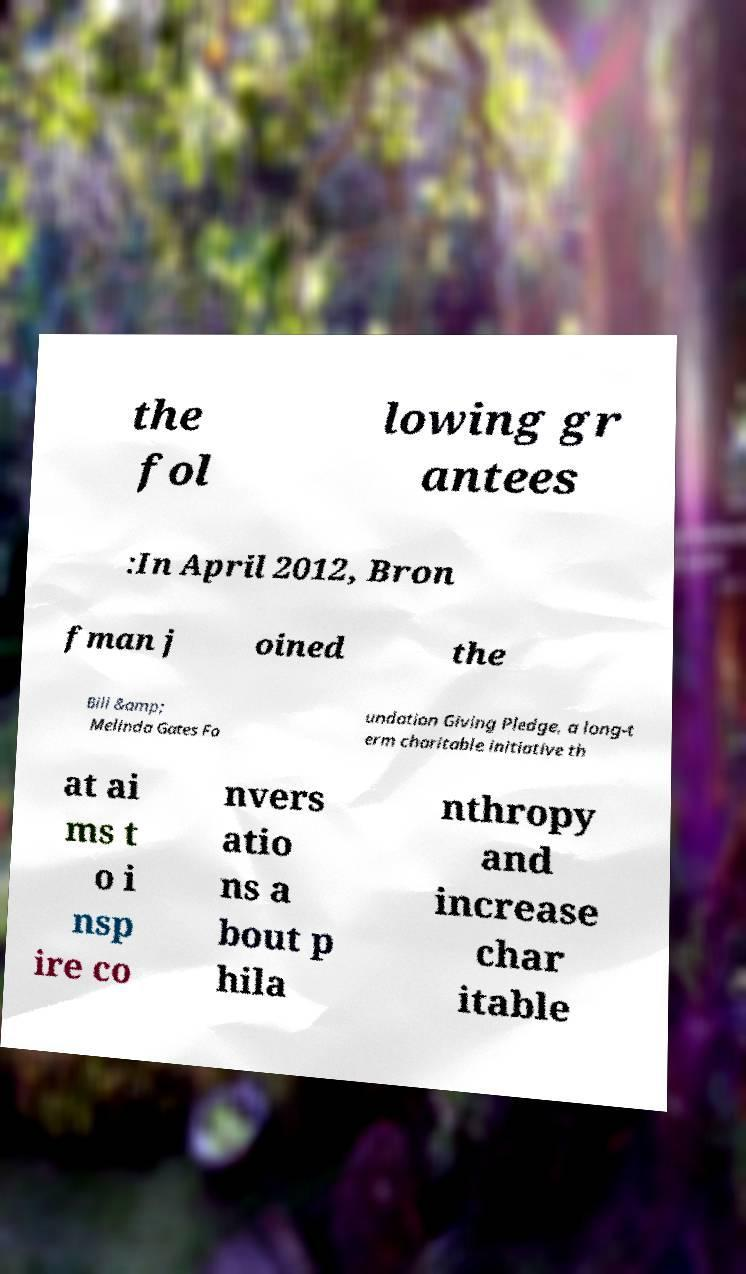Please read and relay the text visible in this image. What does it say? the fol lowing gr antees :In April 2012, Bron fman j oined the Bill &amp; Melinda Gates Fo undation Giving Pledge, a long-t erm charitable initiative th at ai ms t o i nsp ire co nvers atio ns a bout p hila nthropy and increase char itable 